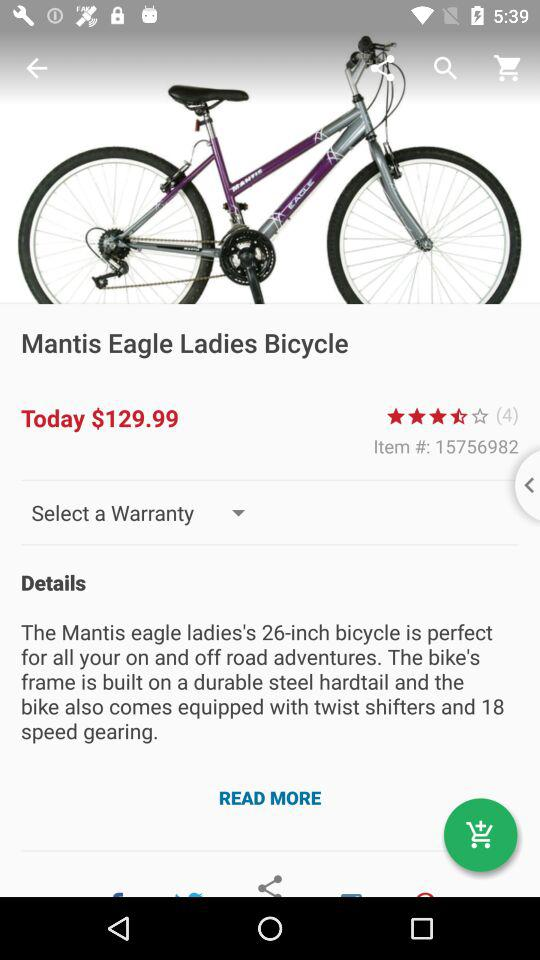What is the ID of the item? The ID is 15756982. 